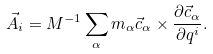<formula> <loc_0><loc_0><loc_500><loc_500>\vec { A } _ { i } = M ^ { - 1 } \sum _ { \alpha } m _ { \alpha } \vec { c } _ { \alpha } \times \frac { \partial \vec { c } _ { \alpha } } { \partial q ^ { i } } .</formula> 